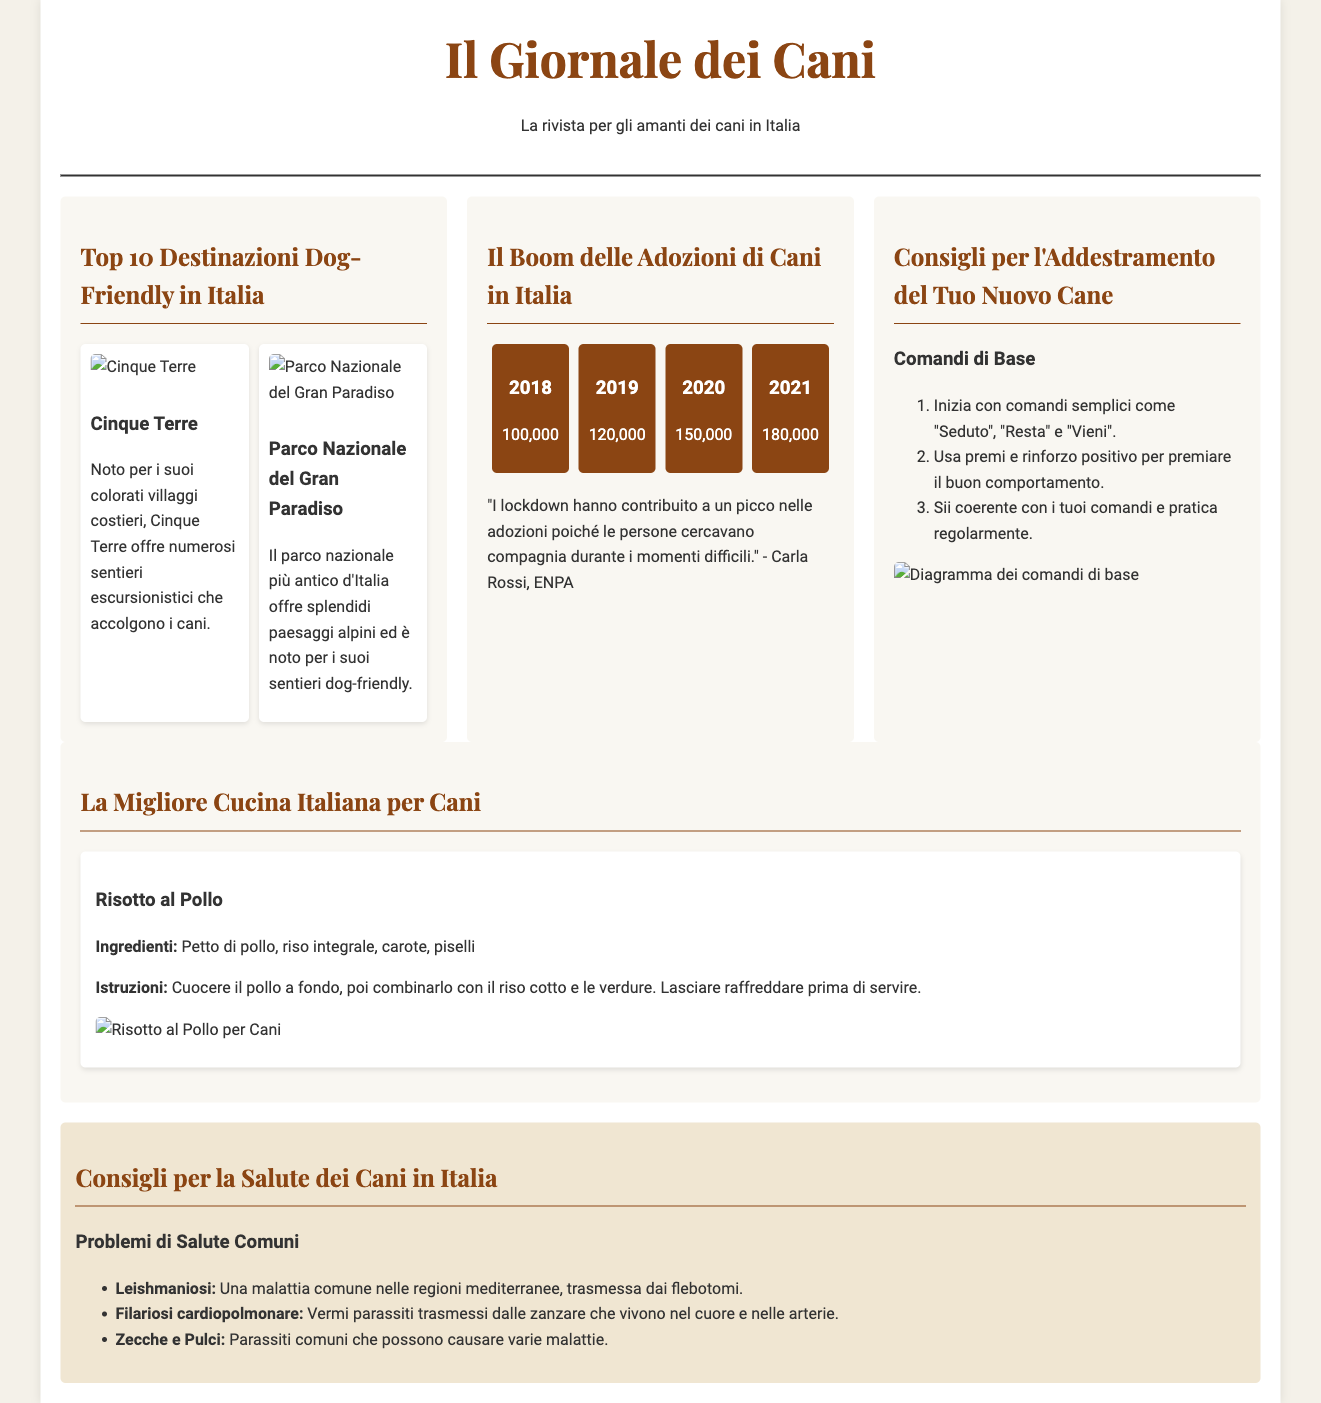What is the name of the newspaper? The name of the newspaper is prominently displayed at the top of the document.
Answer: Il Giornale dei Cani What is the title of the feature article about dog-friendly destinations? The title of the feature article can be found in the section dedicated to dog-friendly travel in Italy.
Answer: Top 10 Destinazioni Dog-Friendly in Italia How many adoptions were recorded in 2021? The statistics section of the investigative report lists the adoption figures by year.
Answer: 180,000 What is the first command suggested for training a new dog? The step-by-step training guide mentions the first command that should be taught.
Answer: Seduto Which dog-friendly destination is mentioned first? The name of the first mentioned destination in the feature article is listed under the dog-friendly destinations section.
Answer: Cinque Terre What is a common health issue for dogs in Italy? The health column outlines various health problems that dogs face in Italy.
Answer: Leishmaniosi What is the main ingredient in the suggested dog recipe? The lifestyle piece shares details about a dog-friendly recipe, including its main ingredient.
Answer: Petto di pollo What year had the lowest recorded adoptions in the statistics section? The statistics section provides a breakdown of adoptions per year, which allows for this determination.
Answer: 2018 What type of advice is provided in the training tips section? The article focuses on providing specific types of training advice for dog owners.
Answer: Expert advice 